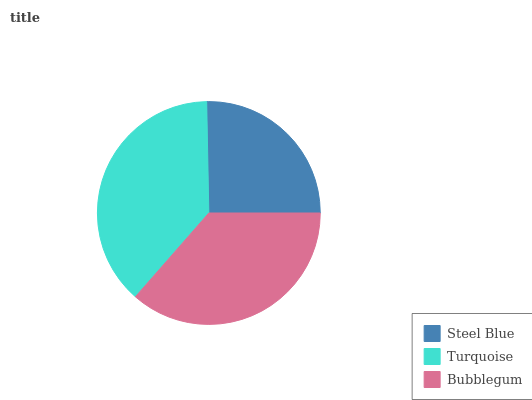Is Steel Blue the minimum?
Answer yes or no. Yes. Is Turquoise the maximum?
Answer yes or no. Yes. Is Bubblegum the minimum?
Answer yes or no. No. Is Bubblegum the maximum?
Answer yes or no. No. Is Turquoise greater than Bubblegum?
Answer yes or no. Yes. Is Bubblegum less than Turquoise?
Answer yes or no. Yes. Is Bubblegum greater than Turquoise?
Answer yes or no. No. Is Turquoise less than Bubblegum?
Answer yes or no. No. Is Bubblegum the high median?
Answer yes or no. Yes. Is Bubblegum the low median?
Answer yes or no. Yes. Is Turquoise the high median?
Answer yes or no. No. Is Steel Blue the low median?
Answer yes or no. No. 